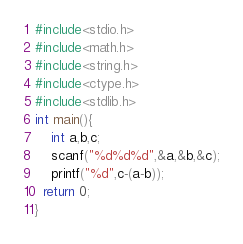Convert code to text. <code><loc_0><loc_0><loc_500><loc_500><_C_>#include<stdio.h>
#include<math.h>
#include<string.h>
#include<ctype.h>
#include<stdlib.h>
int main(){
    int a,b,c;
    scanf("%d%d%d",&a,&b,&c);
    printf("%d",c-(a-b));
  return 0;
}</code> 